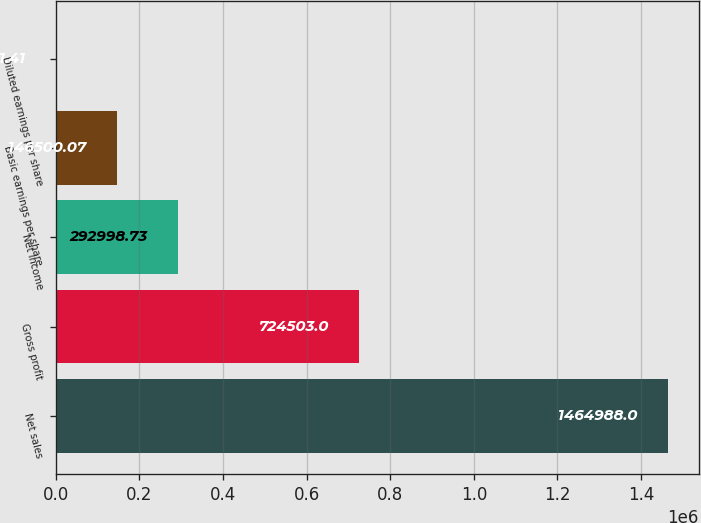Convert chart. <chart><loc_0><loc_0><loc_500><loc_500><bar_chart><fcel>Net sales<fcel>Gross profit<fcel>Net income<fcel>Basic earnings per share<fcel>Diluted earnings per share<nl><fcel>1.46499e+06<fcel>724503<fcel>292999<fcel>146500<fcel>1.41<nl></chart> 